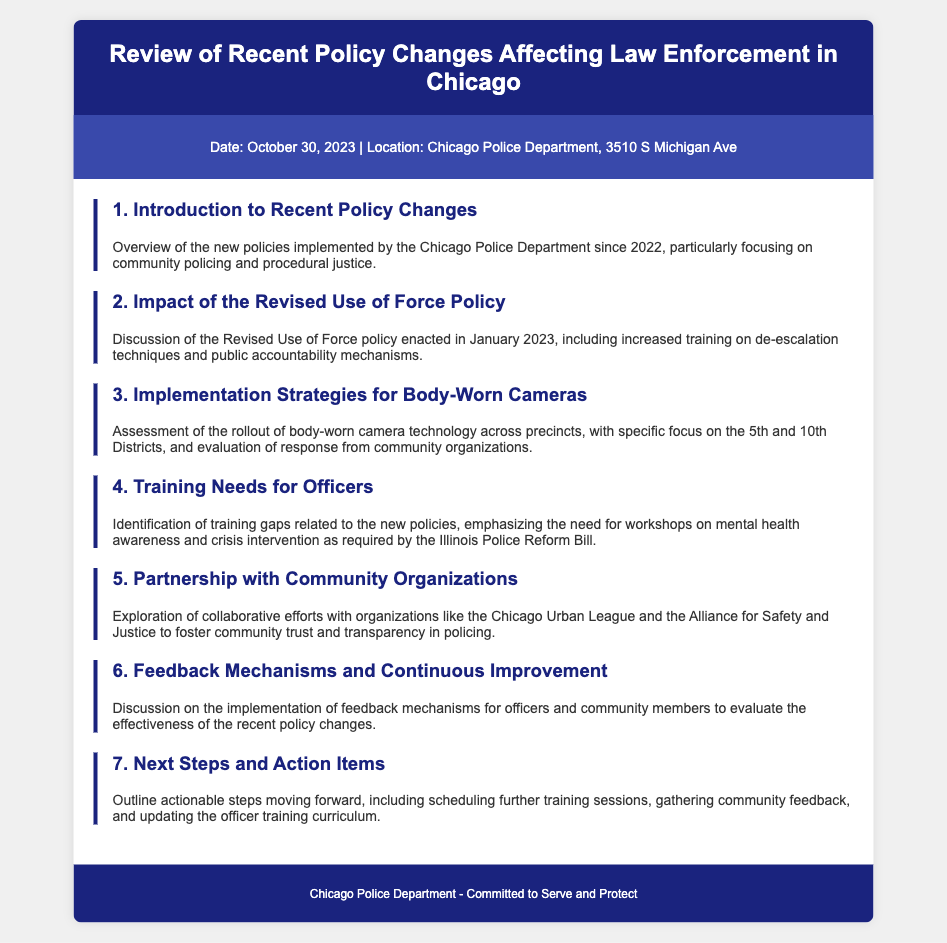what is the date of the meeting? The date of the meeting is listed in the document's meta section, stating October 30, 2023.
Answer: October 30, 2023 where is the meeting located? The location of the meeting is specified in the meta section of the document as the Chicago Police Department, 3510 S Michigan Ave.
Answer: Chicago Police Department, 3510 S Michigan Ave what is the focus of the first agenda item? The first agenda item covers an overview of new policies, particularly community policing and procedural justice.
Answer: community policing and procedural justice which policy was revised in January 2023? The Revised Use of Force policy is detailed in the document as enacted in January 2023.
Answer: Revised Use of Force policy what is one key area identified for officer training? The agenda item on training needs highlights the necessity for workshops on mental health awareness.
Answer: mental health awareness how many districts are focused on in the body-worn camera implementation? The document mentions a specific focus on the 5th and 10th Districts regarding the rollout of body-worn cameras.
Answer: 2 what type of organizations is the police department partnering with? The document refers to partnerships with community organizations aimed at building trust and transparency.
Answer: community organizations what is one method discussed for improving policy effectiveness? The document mentions the implementation of feedback mechanisms for evaluating policy effectiveness.
Answer: feedback mechanisms 